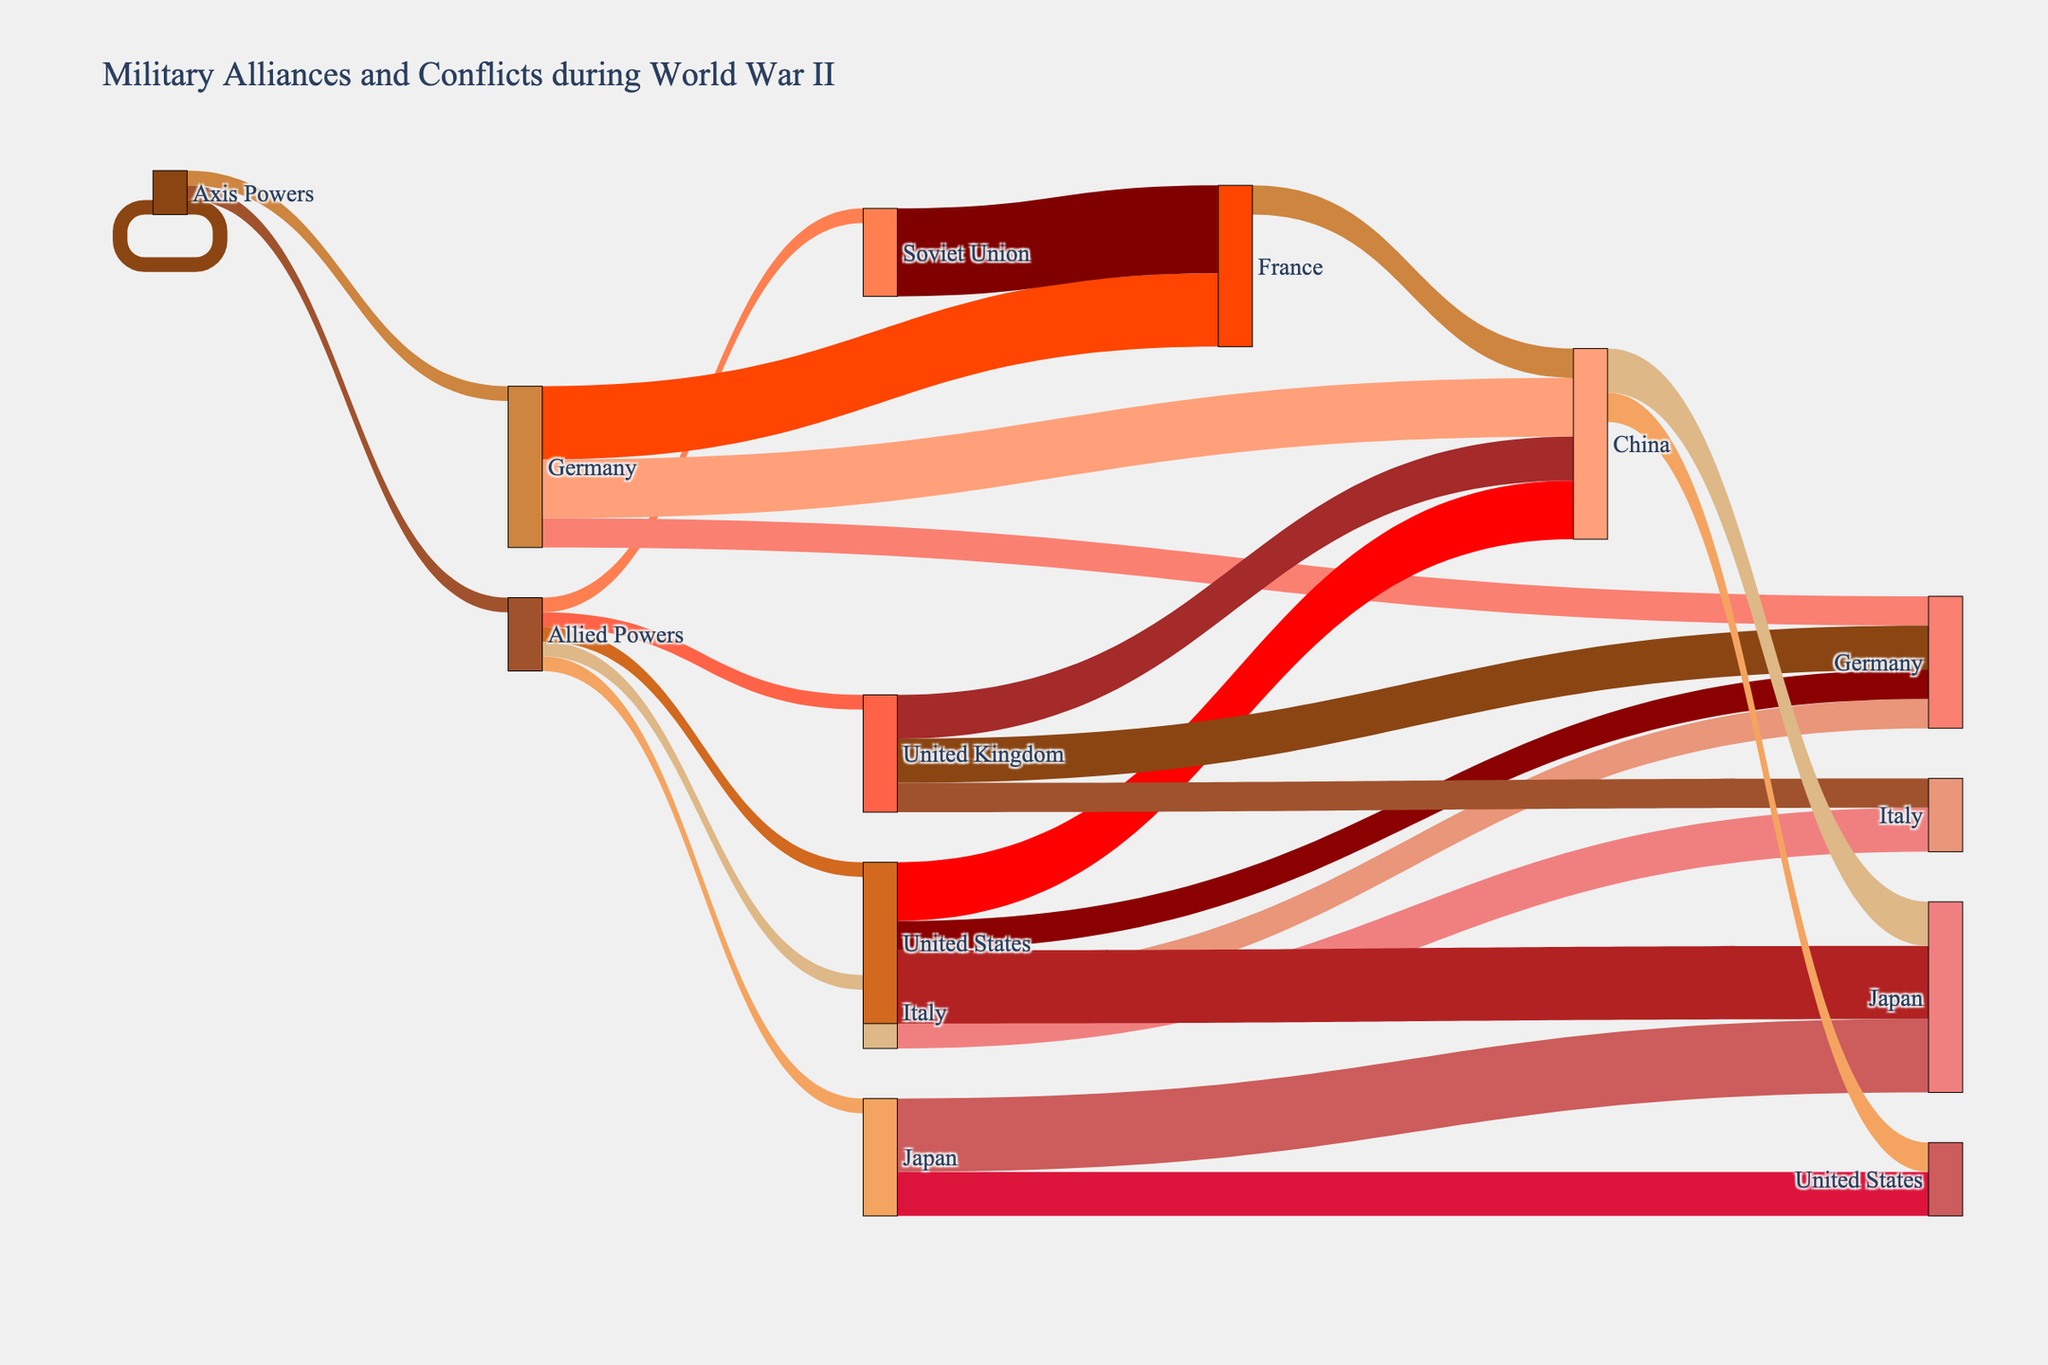Which countries are labeled under the Axis Powers? The figure shows a set of three countries in the Axis Powers category, represented by separate lines leading from "Axis Powers" to these countries.
Answer: Germany, Italy, Japan How many theaters of conflict did Germany participate in according to the figure? The figure displays multiple lines emerging from "Germany" to different theaters of conflict. Count these connections to find the answer.
Answer: 3 Which faction has the highest number of member countries? Compare the number of countries connected to "Axis Powers" and "Allied Powers". The faction with more connections has the higher number of member countries.
Answer: Allied Powers What is the total number of conflicts depicted for the United States? Identify the lines leading from "United States" to various conflict areas and sum up the values. The United States is connected to the Pacific Theater (5), Western Front (4), and North African Campaign (2). Therefore, the total is 5 + 4 + 2.
Answer: 11 Which country is involved in the most theaters of conflict? Count the connections leading from each country to different theaters. The country with the most connections is involved in the highest number of conflicts.
Answer: United Kingdom How many theaters of conflict are the Allied Powers collectively involved in? Add up the unique conflict areas connected to each country under the Allied Powers. The total unique conflicts are Pacific Theater, Western Front, North African Campaign, Mediterranean Theater, Eastern Front, and Southeast Asian Theater.
Answer: 6 Which conflict has the highest number of connections from different countries? Identify the theater of conflict with the most lines connecting from various countries. The conflict with the highest number of connections wins.
Answer: Western Front Compare the involvement in the Pacific Theater between the Axis Powers and Allied Powers. Observe the lines connecting to the Pacific Theater from Japan (Axis) and United States, China (Allied). Count and compare these connections. Axis Powers have 1 country (Japan: 5) involved, while Allied Powers have 2 countries (US: 5 and China: 3), showing more involvement from the Allied Powers.
Answer: Allied Powers What is the combined involvement of Germany and Italy in the North African Campaign? Sum the values of the lines leading from Germany and Italy to the North African Campaign. Germany (2) + Italy (2) yields the total involvement.
Answer: 4 How many countries are involved in the Mediterranean Theater? Count the distinct countries with lines leading to the Mediterranean Theater. The figure shows connections from Italy and the United Kingdom.
Answer: 2 